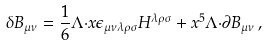<formula> <loc_0><loc_0><loc_500><loc_500>\delta B _ { \mu \nu } = \frac { 1 } { 6 } \Lambda { \cdot x } \epsilon _ { \mu \nu \lambda \rho \sigma } H ^ { \lambda \rho \sigma } + x ^ { 5 } \Lambda { \cdot \partial } B _ { \mu \nu } \, ,</formula> 